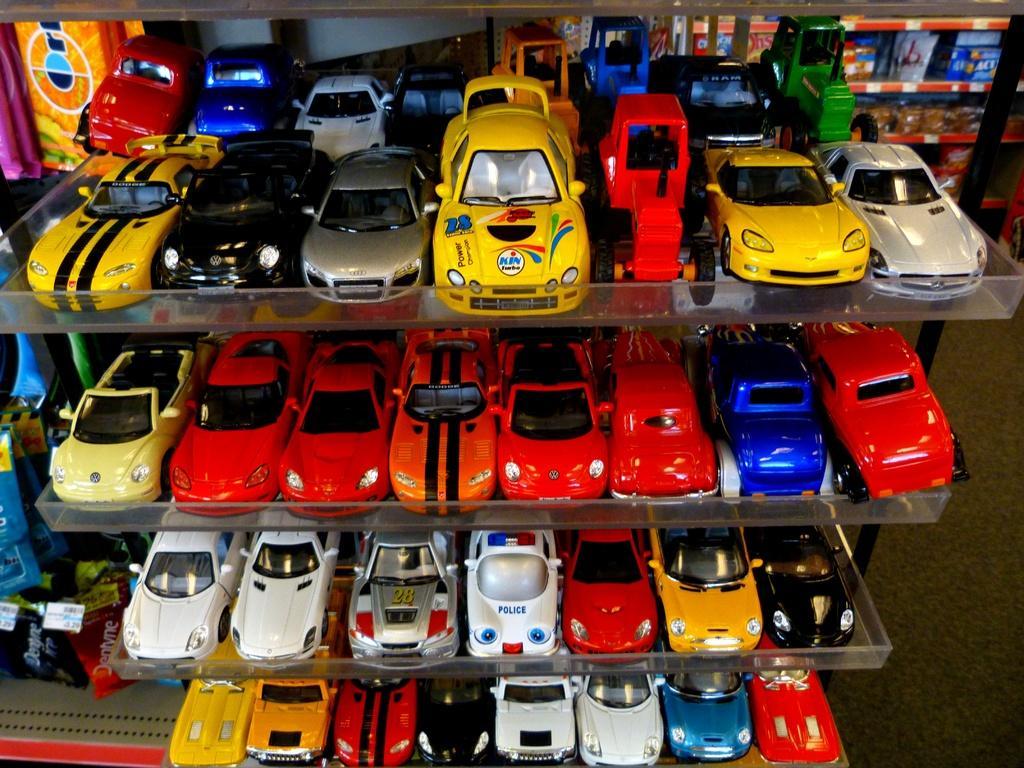Describe this image in one or two sentences. In this image there are so many toy cars kept on the plastic racks. 